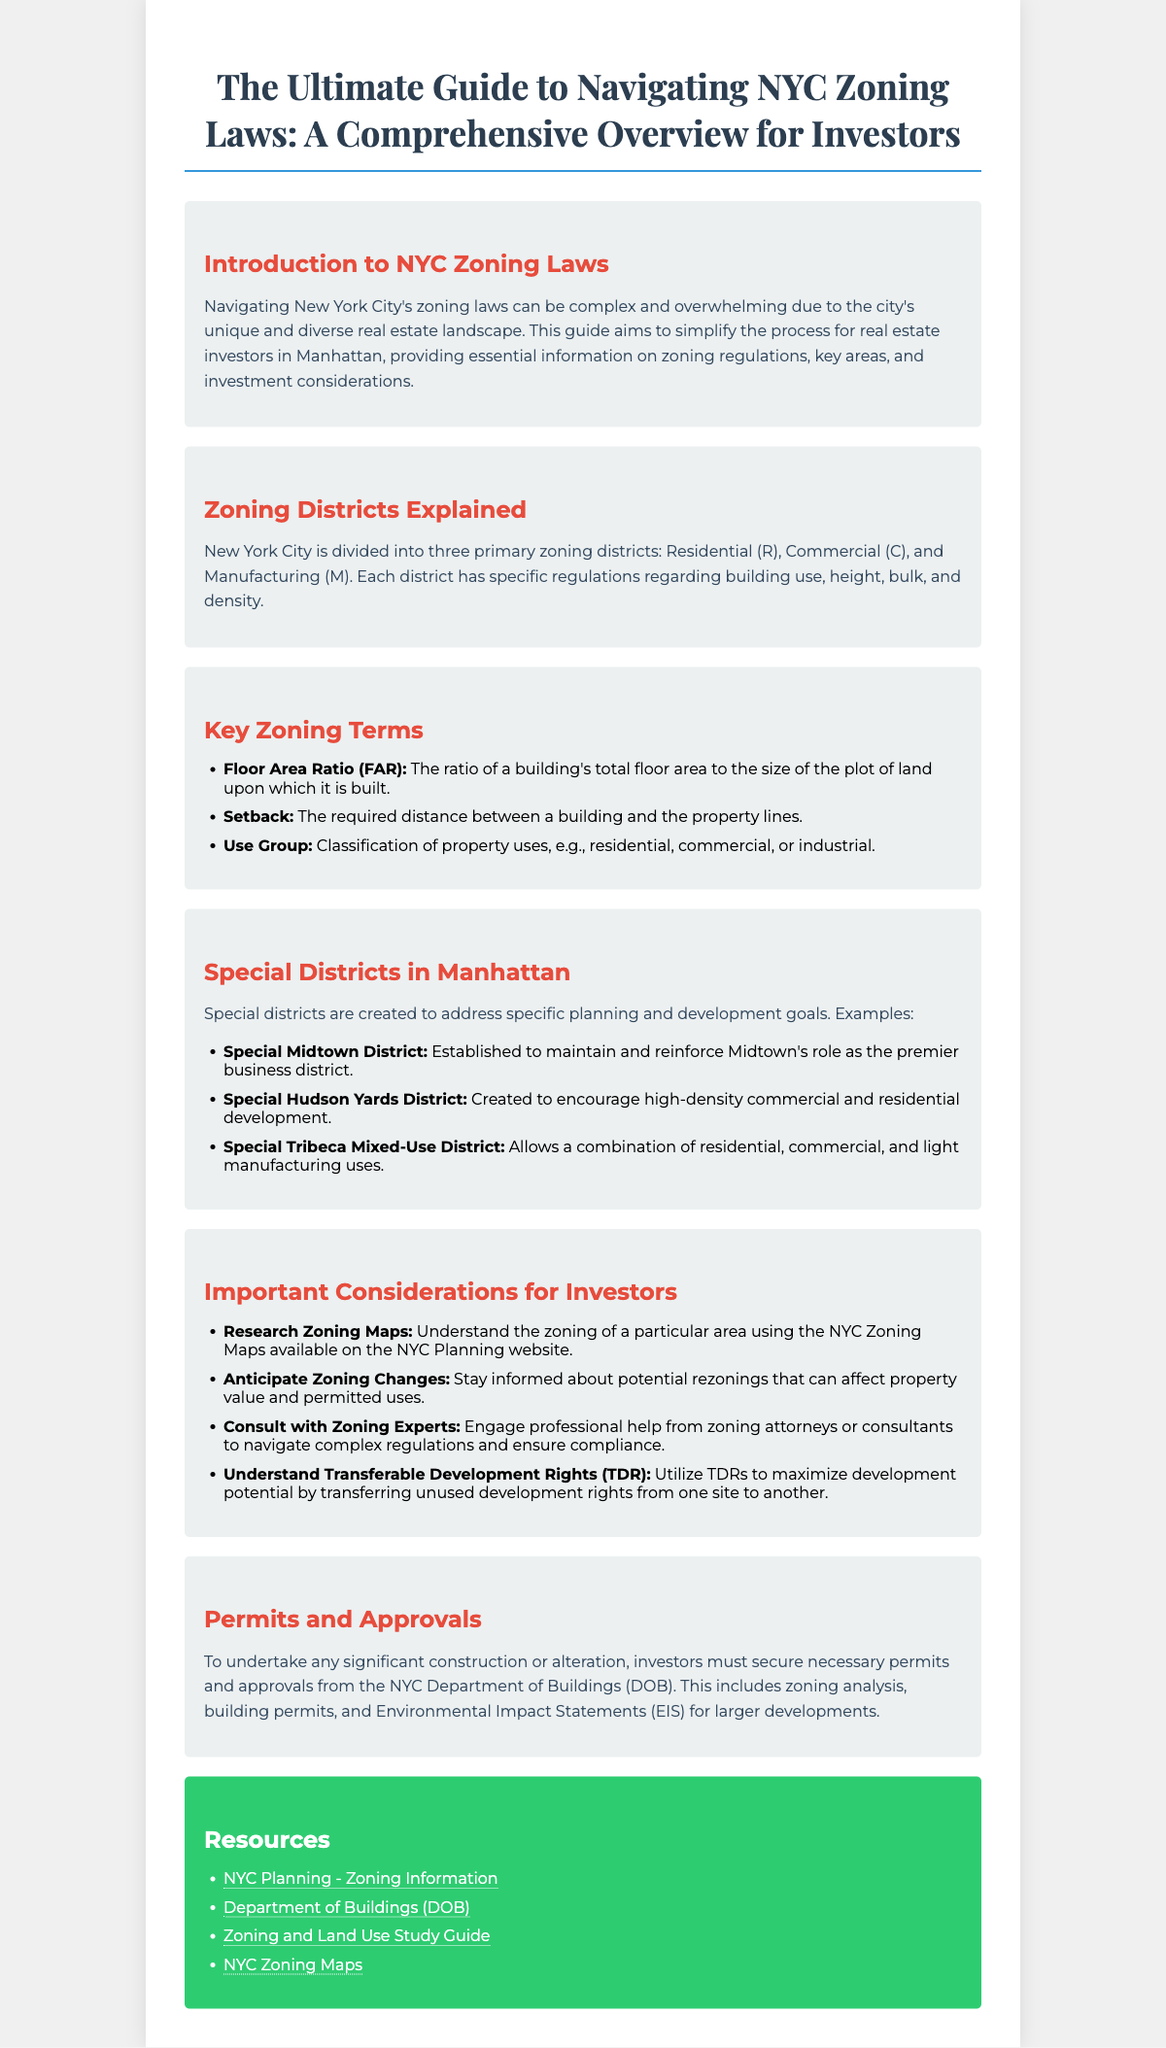What are the three primary zoning districts in NYC? The document lists the primary zoning districts as Residential (R), Commercial (C), and Manufacturing (M).
Answer: Residential (R), Commercial (C), Manufacturing (M) What does FAR stand for? FAR refers to the Floor Area Ratio, as defined in the Key Zoning Terms section.
Answer: Floor Area Ratio What is the purpose of the Special Midtown District? The purpose is to maintain and reinforce Midtown's role as the premier business district.
Answer: Maintain and reinforce Midtown's role What does TDR stand for? TDR refers to Transferable Development Rights, mentioned in the Important Considerations for Investors section.
Answer: Transferable Development Rights Where can you find NYC Zoning Maps? The document provides a link to the NYC Zoning Maps in the Resources section.
Answer: NYC Zoning Maps link What essential action must investors take before construction? The document states investors must secure necessary permits and approvals from the NYC Department of Buildings (DOB) before construction.
Answer: Secure necessary permits Which district encourages high-density commercial development? The Special Hudson Yards District is created to encourage high-density commercial and residential development, as listed.
Answer: Special Hudson Yards District What does 'Setback' refer to? Setback is defined as the required distance between a building and the property lines, according to the Key Zoning Terms.
Answer: Required distance between a building and property lines What is a recommended resource for zoning information? One recommended resource is the NYC Planning - Zoning Information page found in the Resources section.
Answer: NYC Planning - Zoning Information 